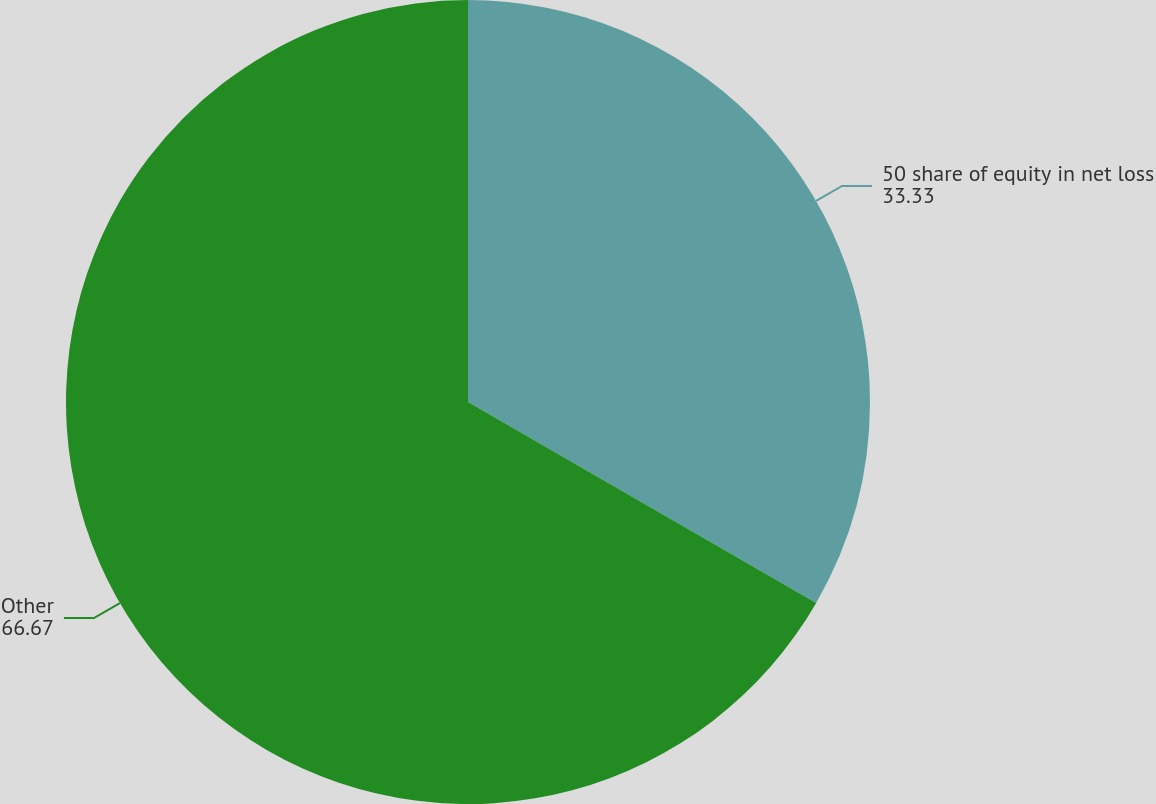Convert chart to OTSL. <chart><loc_0><loc_0><loc_500><loc_500><pie_chart><fcel>50 share of equity in net loss<fcel>Other<nl><fcel>33.33%<fcel>66.67%<nl></chart> 